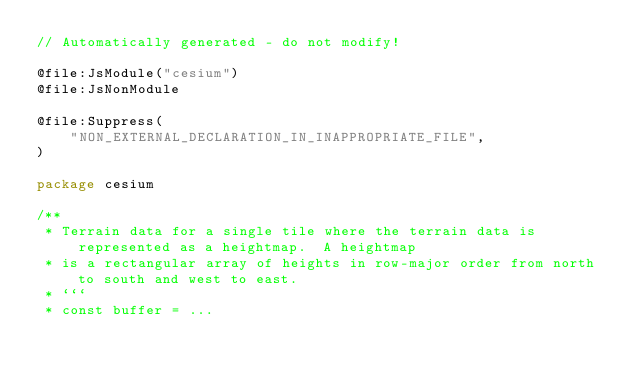Convert code to text. <code><loc_0><loc_0><loc_500><loc_500><_Kotlin_>// Automatically generated - do not modify!

@file:JsModule("cesium")
@file:JsNonModule

@file:Suppress(
    "NON_EXTERNAL_DECLARATION_IN_INAPPROPRIATE_FILE",
)

package cesium

/**
 * Terrain data for a single tile where the terrain data is represented as a heightmap.  A heightmap
 * is a rectangular array of heights in row-major order from north to south and west to east.
 * ```
 * const buffer = ...</code> 